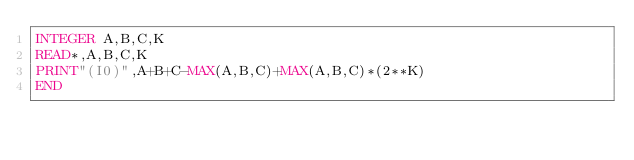<code> <loc_0><loc_0><loc_500><loc_500><_FORTRAN_>INTEGER A,B,C,K
READ*,A,B,C,K
PRINT"(I0)",A+B+C-MAX(A,B,C)+MAX(A,B,C)*(2**K)
END</code> 